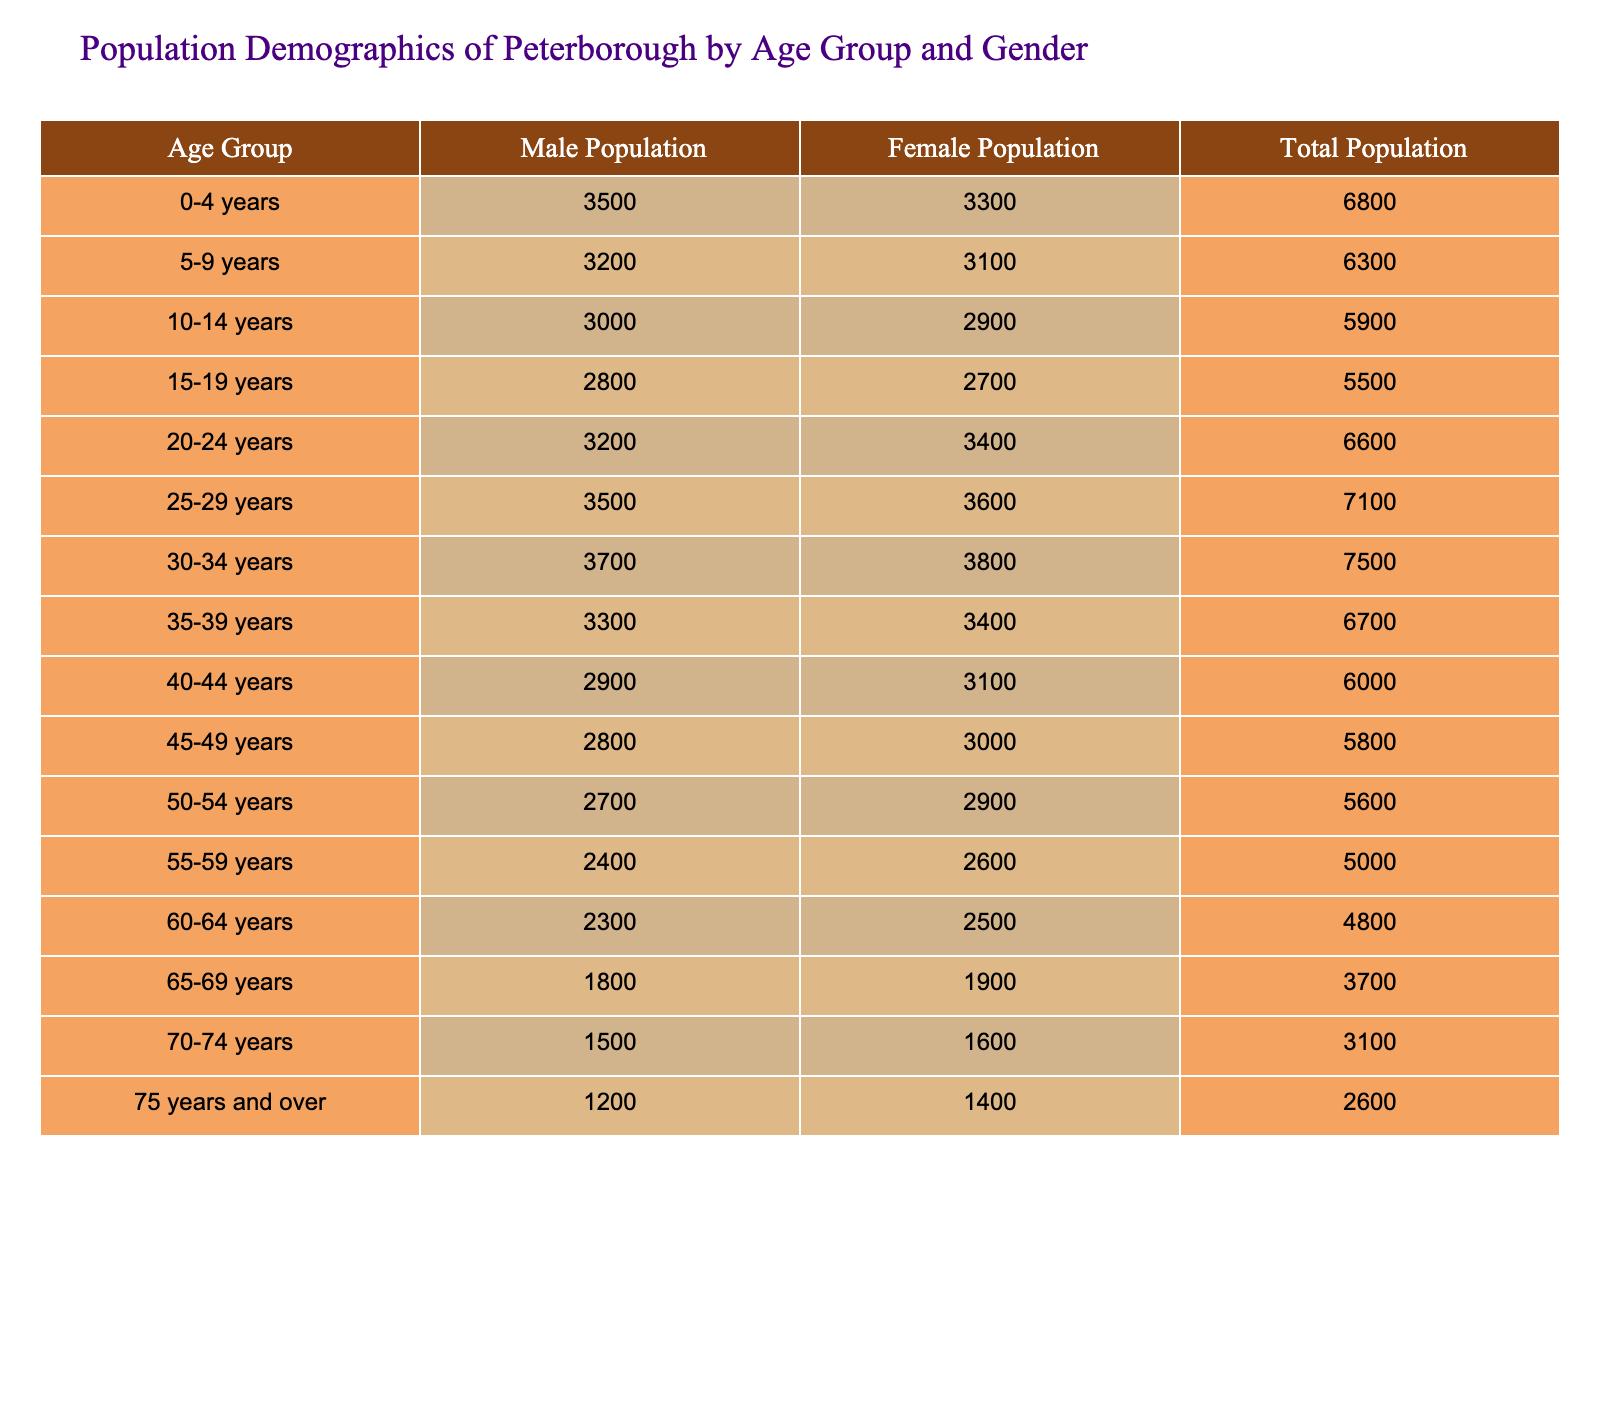What is the total population of the age group 30-34 years? To find the total population for the age group 30-34 years, we refer to the table and locate that age group. The table indicates that the total population for this group is 7500.
Answer: 7500 What is the female population in the age group 40-44 years? Referring to the table, we look for the female population data in the relevant age group, which is listed as 3100 for the age group 40-44 years.
Answer: 3100 What is the difference between the male and female populations in the age group 25-29 years? For the age group 25-29 years, the male population is 3500 and the female population is 3600. The difference can be calculated as 3600 - 3500 = 100.
Answer: 100 How many people are there in the age group 15-19 years compared to the 75 years and over group? The population for the age group 15-19 years is 5500, while for the 75 years and over group, it is 2600. The comparison shows that 5500 is much larger than 2600, specifically there are 5500 - 2600 = 2900 more people in the 15-19 age group.
Answer: 2900 Which age group has the highest total population? By examining the total population values in the table, the age group 25-29 years has the highest total population at 7100, which is greater than all other age groups listed.
Answer: 25-29 years Is the male population in the age group 60-64 years greater than the female population in the same age group? Looking at the table, the male population for the age group 60-64 years is 2300 and the female population is 2500. Since 2300 is less than 2500, the statement is false.
Answer: No What is the average total population across all age groups? To calculate the average total population, we sum all total population values from each age group: 6800 + 6300 + 5900 + 5500 + 6600 + 7100 + 7500 + 6700 + 6000 + 5800 + 5600 + 5000 + 4800 + 3700 + 3100 + 2600 = 102,600. There are 16 age groups, so the average is 102600 / 16 = 6412.5.
Answer: 6412.5 In how many age groups does the male population exceed 3000? Referring to the male population values in the table, we observe that the male population exceeds 3000 in the following groups: 0-4, 5-9, 10-14, 15-19, 20-24, 25-29, 30-34, 35-39, 40-44, 45-49, 50-54, and 55-59. This results in a total of 12 age groups.
Answer: 12 Which gender has a higher population in the age group 70-74 years? In looking at the table's data for the age group 70-74 years, the male population is 1500, whereas the female population is 1600. As the female population is higher, the answer is female.
Answer: Female 